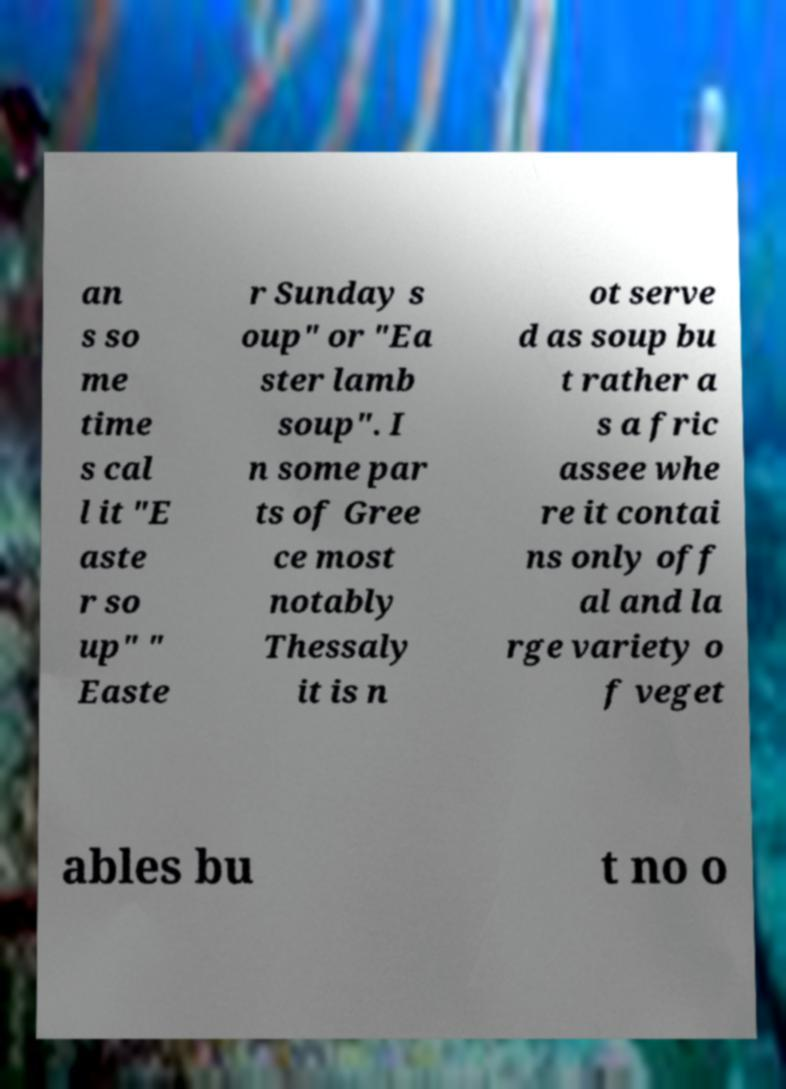Could you extract and type out the text from this image? an s so me time s cal l it "E aste r so up" " Easte r Sunday s oup" or "Ea ster lamb soup". I n some par ts of Gree ce most notably Thessaly it is n ot serve d as soup bu t rather a s a fric assee whe re it contai ns only off al and la rge variety o f veget ables bu t no o 